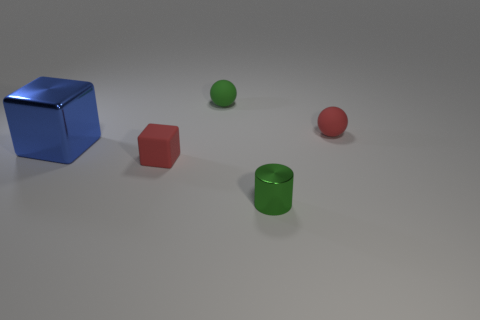There is a blue cube; are there any green things in front of it?
Your answer should be very brief. Yes. How many other objects are the same shape as the green metal object?
Keep it short and to the point. 0. What color is the shiny object that is the same size as the green rubber ball?
Ensure brevity in your answer.  Green. Are there fewer matte things that are on the left side of the large blue block than shiny things that are in front of the small green cylinder?
Your answer should be compact. No. What number of tiny objects are behind the tiny red object that is left of the red matte object right of the tiny green matte ball?
Keep it short and to the point. 2. What is the size of the other object that is the same shape as the big shiny object?
Provide a short and direct response. Small. Is there any other thing that is the same size as the metal cylinder?
Your answer should be compact. Yes. Is the number of red matte cubes on the left side of the large blue metal cube less than the number of small blocks?
Ensure brevity in your answer.  Yes. Does the blue metal thing have the same shape as the small green metal object?
Offer a very short reply. No. There is another rubber thing that is the same shape as the large object; what color is it?
Your response must be concise. Red. 